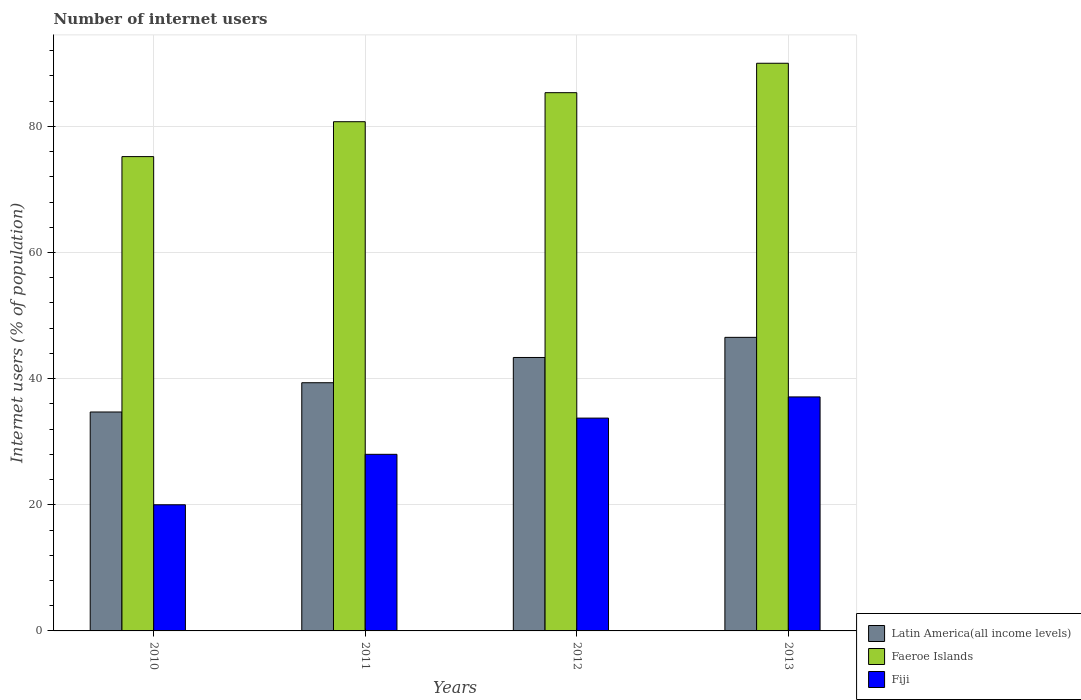How many different coloured bars are there?
Give a very brief answer. 3. How many bars are there on the 4th tick from the right?
Your response must be concise. 3. What is the label of the 2nd group of bars from the left?
Provide a short and direct response. 2011. What is the number of internet users in Faeroe Islands in 2010?
Your response must be concise. 75.2. Across all years, what is the minimum number of internet users in Latin America(all income levels)?
Your response must be concise. 34.71. In which year was the number of internet users in Latin America(all income levels) maximum?
Offer a terse response. 2013. What is the total number of internet users in Latin America(all income levels) in the graph?
Offer a very short reply. 163.96. What is the difference between the number of internet users in Faeroe Islands in 2010 and that in 2013?
Your answer should be very brief. -14.8. What is the difference between the number of internet users in Faeroe Islands in 2010 and the number of internet users in Fiji in 2012?
Give a very brief answer. 41.46. What is the average number of internet users in Faeroe Islands per year?
Make the answer very short. 82.82. In the year 2010, what is the difference between the number of internet users in Faeroe Islands and number of internet users in Fiji?
Keep it short and to the point. 55.2. What is the ratio of the number of internet users in Latin America(all income levels) in 2010 to that in 2011?
Provide a short and direct response. 0.88. Is the number of internet users in Latin America(all income levels) in 2012 less than that in 2013?
Your answer should be compact. Yes. Is the difference between the number of internet users in Faeroe Islands in 2010 and 2011 greater than the difference between the number of internet users in Fiji in 2010 and 2011?
Make the answer very short. Yes. What is the difference between the highest and the second highest number of internet users in Latin America(all income levels)?
Provide a succinct answer. 3.19. What is the difference between the highest and the lowest number of internet users in Fiji?
Offer a terse response. 17.1. In how many years, is the number of internet users in Faeroe Islands greater than the average number of internet users in Faeroe Islands taken over all years?
Your response must be concise. 2. What does the 1st bar from the left in 2013 represents?
Offer a terse response. Latin America(all income levels). What does the 2nd bar from the right in 2012 represents?
Provide a short and direct response. Faeroe Islands. Is it the case that in every year, the sum of the number of internet users in Faeroe Islands and number of internet users in Fiji is greater than the number of internet users in Latin America(all income levels)?
Provide a succinct answer. Yes. How many bars are there?
Give a very brief answer. 12. Are all the bars in the graph horizontal?
Give a very brief answer. No. How many years are there in the graph?
Your response must be concise. 4. What is the difference between two consecutive major ticks on the Y-axis?
Provide a short and direct response. 20. Are the values on the major ticks of Y-axis written in scientific E-notation?
Provide a short and direct response. No. Does the graph contain any zero values?
Offer a very short reply. No. Where does the legend appear in the graph?
Your response must be concise. Bottom right. How many legend labels are there?
Offer a terse response. 3. What is the title of the graph?
Your response must be concise. Number of internet users. Does "Djibouti" appear as one of the legend labels in the graph?
Your response must be concise. No. What is the label or title of the X-axis?
Your response must be concise. Years. What is the label or title of the Y-axis?
Offer a very short reply. Internet users (% of population). What is the Internet users (% of population) of Latin America(all income levels) in 2010?
Give a very brief answer. 34.71. What is the Internet users (% of population) of Faeroe Islands in 2010?
Your response must be concise. 75.2. What is the Internet users (% of population) of Latin America(all income levels) in 2011?
Offer a very short reply. 39.35. What is the Internet users (% of population) of Faeroe Islands in 2011?
Your answer should be very brief. 80.73. What is the Internet users (% of population) in Fiji in 2011?
Offer a terse response. 28. What is the Internet users (% of population) in Latin America(all income levels) in 2012?
Your answer should be compact. 43.35. What is the Internet users (% of population) of Faeroe Islands in 2012?
Your response must be concise. 85.34. What is the Internet users (% of population) of Fiji in 2012?
Keep it short and to the point. 33.74. What is the Internet users (% of population) of Latin America(all income levels) in 2013?
Offer a very short reply. 46.54. What is the Internet users (% of population) in Faeroe Islands in 2013?
Provide a short and direct response. 90. What is the Internet users (% of population) in Fiji in 2013?
Provide a succinct answer. 37.1. Across all years, what is the maximum Internet users (% of population) of Latin America(all income levels)?
Your response must be concise. 46.54. Across all years, what is the maximum Internet users (% of population) of Fiji?
Keep it short and to the point. 37.1. Across all years, what is the minimum Internet users (% of population) of Latin America(all income levels)?
Ensure brevity in your answer.  34.71. Across all years, what is the minimum Internet users (% of population) in Faeroe Islands?
Offer a very short reply. 75.2. Across all years, what is the minimum Internet users (% of population) in Fiji?
Provide a short and direct response. 20. What is the total Internet users (% of population) of Latin America(all income levels) in the graph?
Provide a short and direct response. 163.96. What is the total Internet users (% of population) of Faeroe Islands in the graph?
Provide a short and direct response. 331.27. What is the total Internet users (% of population) in Fiji in the graph?
Your response must be concise. 118.84. What is the difference between the Internet users (% of population) in Latin America(all income levels) in 2010 and that in 2011?
Ensure brevity in your answer.  -4.64. What is the difference between the Internet users (% of population) in Faeroe Islands in 2010 and that in 2011?
Give a very brief answer. -5.53. What is the difference between the Internet users (% of population) in Latin America(all income levels) in 2010 and that in 2012?
Your answer should be very brief. -8.64. What is the difference between the Internet users (% of population) in Faeroe Islands in 2010 and that in 2012?
Offer a very short reply. -10.14. What is the difference between the Internet users (% of population) of Fiji in 2010 and that in 2012?
Provide a succinct answer. -13.74. What is the difference between the Internet users (% of population) of Latin America(all income levels) in 2010 and that in 2013?
Ensure brevity in your answer.  -11.83. What is the difference between the Internet users (% of population) of Faeroe Islands in 2010 and that in 2013?
Offer a very short reply. -14.8. What is the difference between the Internet users (% of population) of Fiji in 2010 and that in 2013?
Your response must be concise. -17.1. What is the difference between the Internet users (% of population) in Latin America(all income levels) in 2011 and that in 2012?
Give a very brief answer. -4. What is the difference between the Internet users (% of population) of Faeroe Islands in 2011 and that in 2012?
Provide a short and direct response. -4.6. What is the difference between the Internet users (% of population) in Fiji in 2011 and that in 2012?
Provide a short and direct response. -5.74. What is the difference between the Internet users (% of population) in Latin America(all income levels) in 2011 and that in 2013?
Your answer should be compact. -7.19. What is the difference between the Internet users (% of population) in Faeroe Islands in 2011 and that in 2013?
Provide a succinct answer. -9.27. What is the difference between the Internet users (% of population) in Latin America(all income levels) in 2012 and that in 2013?
Offer a very short reply. -3.19. What is the difference between the Internet users (% of population) in Faeroe Islands in 2012 and that in 2013?
Provide a short and direct response. -4.66. What is the difference between the Internet users (% of population) of Fiji in 2012 and that in 2013?
Offer a very short reply. -3.36. What is the difference between the Internet users (% of population) in Latin America(all income levels) in 2010 and the Internet users (% of population) in Faeroe Islands in 2011?
Offer a terse response. -46.02. What is the difference between the Internet users (% of population) in Latin America(all income levels) in 2010 and the Internet users (% of population) in Fiji in 2011?
Make the answer very short. 6.71. What is the difference between the Internet users (% of population) in Faeroe Islands in 2010 and the Internet users (% of population) in Fiji in 2011?
Offer a terse response. 47.2. What is the difference between the Internet users (% of population) of Latin America(all income levels) in 2010 and the Internet users (% of population) of Faeroe Islands in 2012?
Make the answer very short. -50.62. What is the difference between the Internet users (% of population) in Faeroe Islands in 2010 and the Internet users (% of population) in Fiji in 2012?
Your response must be concise. 41.46. What is the difference between the Internet users (% of population) of Latin America(all income levels) in 2010 and the Internet users (% of population) of Faeroe Islands in 2013?
Your answer should be compact. -55.29. What is the difference between the Internet users (% of population) of Latin America(all income levels) in 2010 and the Internet users (% of population) of Fiji in 2013?
Your answer should be very brief. -2.39. What is the difference between the Internet users (% of population) in Faeroe Islands in 2010 and the Internet users (% of population) in Fiji in 2013?
Keep it short and to the point. 38.1. What is the difference between the Internet users (% of population) in Latin America(all income levels) in 2011 and the Internet users (% of population) in Faeroe Islands in 2012?
Give a very brief answer. -45.99. What is the difference between the Internet users (% of population) of Latin America(all income levels) in 2011 and the Internet users (% of population) of Fiji in 2012?
Keep it short and to the point. 5.61. What is the difference between the Internet users (% of population) of Faeroe Islands in 2011 and the Internet users (% of population) of Fiji in 2012?
Offer a very short reply. 46.99. What is the difference between the Internet users (% of population) in Latin America(all income levels) in 2011 and the Internet users (% of population) in Faeroe Islands in 2013?
Ensure brevity in your answer.  -50.65. What is the difference between the Internet users (% of population) in Latin America(all income levels) in 2011 and the Internet users (% of population) in Fiji in 2013?
Provide a succinct answer. 2.25. What is the difference between the Internet users (% of population) in Faeroe Islands in 2011 and the Internet users (% of population) in Fiji in 2013?
Ensure brevity in your answer.  43.63. What is the difference between the Internet users (% of population) of Latin America(all income levels) in 2012 and the Internet users (% of population) of Faeroe Islands in 2013?
Keep it short and to the point. -46.65. What is the difference between the Internet users (% of population) of Latin America(all income levels) in 2012 and the Internet users (% of population) of Fiji in 2013?
Your answer should be very brief. 6.25. What is the difference between the Internet users (% of population) in Faeroe Islands in 2012 and the Internet users (% of population) in Fiji in 2013?
Give a very brief answer. 48.24. What is the average Internet users (% of population) in Latin America(all income levels) per year?
Offer a very short reply. 40.99. What is the average Internet users (% of population) of Faeroe Islands per year?
Give a very brief answer. 82.82. What is the average Internet users (% of population) in Fiji per year?
Offer a very short reply. 29.71. In the year 2010, what is the difference between the Internet users (% of population) of Latin America(all income levels) and Internet users (% of population) of Faeroe Islands?
Provide a succinct answer. -40.49. In the year 2010, what is the difference between the Internet users (% of population) in Latin America(all income levels) and Internet users (% of population) in Fiji?
Offer a very short reply. 14.71. In the year 2010, what is the difference between the Internet users (% of population) of Faeroe Islands and Internet users (% of population) of Fiji?
Ensure brevity in your answer.  55.2. In the year 2011, what is the difference between the Internet users (% of population) in Latin America(all income levels) and Internet users (% of population) in Faeroe Islands?
Provide a short and direct response. -41.38. In the year 2011, what is the difference between the Internet users (% of population) of Latin America(all income levels) and Internet users (% of population) of Fiji?
Offer a very short reply. 11.35. In the year 2011, what is the difference between the Internet users (% of population) in Faeroe Islands and Internet users (% of population) in Fiji?
Keep it short and to the point. 52.73. In the year 2012, what is the difference between the Internet users (% of population) of Latin America(all income levels) and Internet users (% of population) of Faeroe Islands?
Your answer should be very brief. -41.98. In the year 2012, what is the difference between the Internet users (% of population) of Latin America(all income levels) and Internet users (% of population) of Fiji?
Your answer should be very brief. 9.61. In the year 2012, what is the difference between the Internet users (% of population) of Faeroe Islands and Internet users (% of population) of Fiji?
Your answer should be compact. 51.59. In the year 2013, what is the difference between the Internet users (% of population) in Latin America(all income levels) and Internet users (% of population) in Faeroe Islands?
Provide a short and direct response. -43.46. In the year 2013, what is the difference between the Internet users (% of population) of Latin America(all income levels) and Internet users (% of population) of Fiji?
Your answer should be compact. 9.44. In the year 2013, what is the difference between the Internet users (% of population) of Faeroe Islands and Internet users (% of population) of Fiji?
Your response must be concise. 52.9. What is the ratio of the Internet users (% of population) of Latin America(all income levels) in 2010 to that in 2011?
Keep it short and to the point. 0.88. What is the ratio of the Internet users (% of population) of Faeroe Islands in 2010 to that in 2011?
Provide a short and direct response. 0.93. What is the ratio of the Internet users (% of population) in Latin America(all income levels) in 2010 to that in 2012?
Your response must be concise. 0.8. What is the ratio of the Internet users (% of population) of Faeroe Islands in 2010 to that in 2012?
Provide a succinct answer. 0.88. What is the ratio of the Internet users (% of population) of Fiji in 2010 to that in 2012?
Offer a terse response. 0.59. What is the ratio of the Internet users (% of population) of Latin America(all income levels) in 2010 to that in 2013?
Offer a very short reply. 0.75. What is the ratio of the Internet users (% of population) in Faeroe Islands in 2010 to that in 2013?
Your answer should be very brief. 0.84. What is the ratio of the Internet users (% of population) of Fiji in 2010 to that in 2013?
Your answer should be very brief. 0.54. What is the ratio of the Internet users (% of population) in Latin America(all income levels) in 2011 to that in 2012?
Ensure brevity in your answer.  0.91. What is the ratio of the Internet users (% of population) of Faeroe Islands in 2011 to that in 2012?
Your response must be concise. 0.95. What is the ratio of the Internet users (% of population) in Fiji in 2011 to that in 2012?
Provide a succinct answer. 0.83. What is the ratio of the Internet users (% of population) of Latin America(all income levels) in 2011 to that in 2013?
Your response must be concise. 0.85. What is the ratio of the Internet users (% of population) in Faeroe Islands in 2011 to that in 2013?
Keep it short and to the point. 0.9. What is the ratio of the Internet users (% of population) in Fiji in 2011 to that in 2013?
Your answer should be compact. 0.75. What is the ratio of the Internet users (% of population) in Latin America(all income levels) in 2012 to that in 2013?
Provide a short and direct response. 0.93. What is the ratio of the Internet users (% of population) in Faeroe Islands in 2012 to that in 2013?
Give a very brief answer. 0.95. What is the ratio of the Internet users (% of population) in Fiji in 2012 to that in 2013?
Your response must be concise. 0.91. What is the difference between the highest and the second highest Internet users (% of population) of Latin America(all income levels)?
Make the answer very short. 3.19. What is the difference between the highest and the second highest Internet users (% of population) of Faeroe Islands?
Provide a short and direct response. 4.66. What is the difference between the highest and the second highest Internet users (% of population) in Fiji?
Make the answer very short. 3.36. What is the difference between the highest and the lowest Internet users (% of population) of Latin America(all income levels)?
Provide a succinct answer. 11.83. 